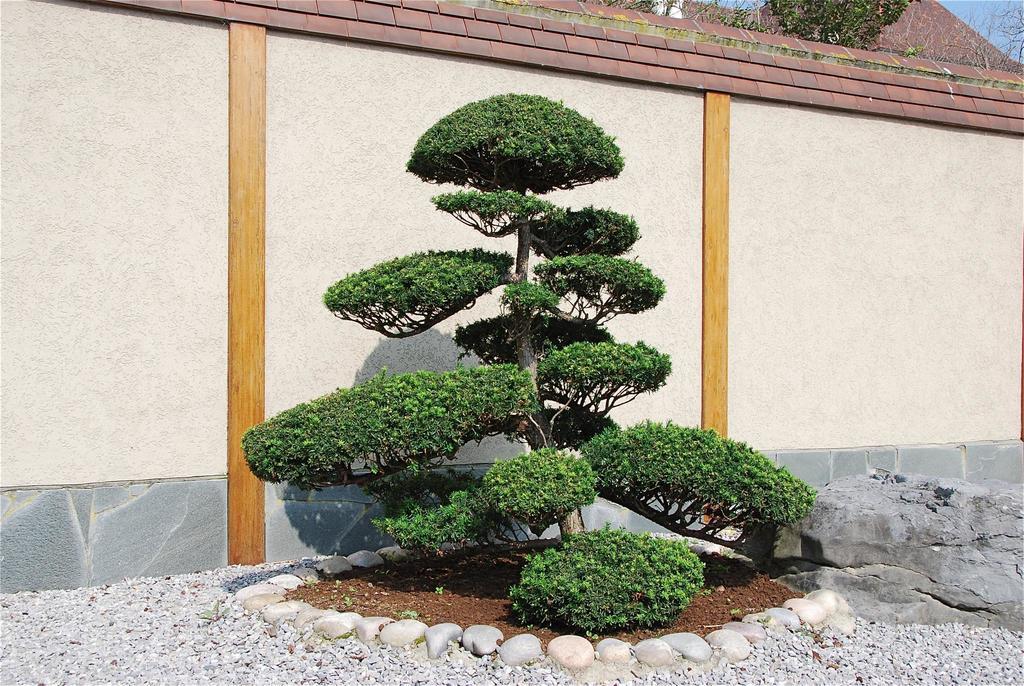How would you summarize this image in a sentence or two? In this image there are trees and we can see a wall. At the bottom there are stones. 